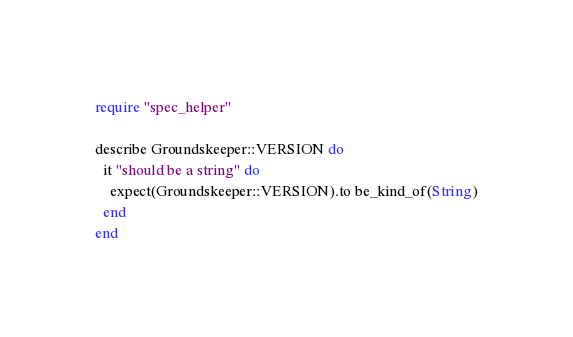Convert code to text. <code><loc_0><loc_0><loc_500><loc_500><_Ruby_>require "spec_helper"

describe Groundskeeper::VERSION do
  it "should be a string" do
    expect(Groundskeeper::VERSION).to be_kind_of(String)
  end
end
</code> 